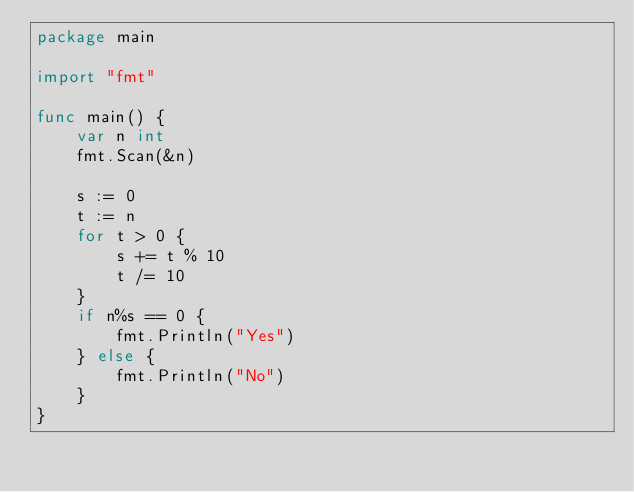Convert code to text. <code><loc_0><loc_0><loc_500><loc_500><_Go_>package main

import "fmt"

func main() {
	var n int
	fmt.Scan(&n)

	s := 0
	t := n
	for t > 0 {
		s += t % 10
		t /= 10
	}
	if n%s == 0 {
		fmt.Println("Yes")
	} else {
		fmt.Println("No")
	}
}
</code> 